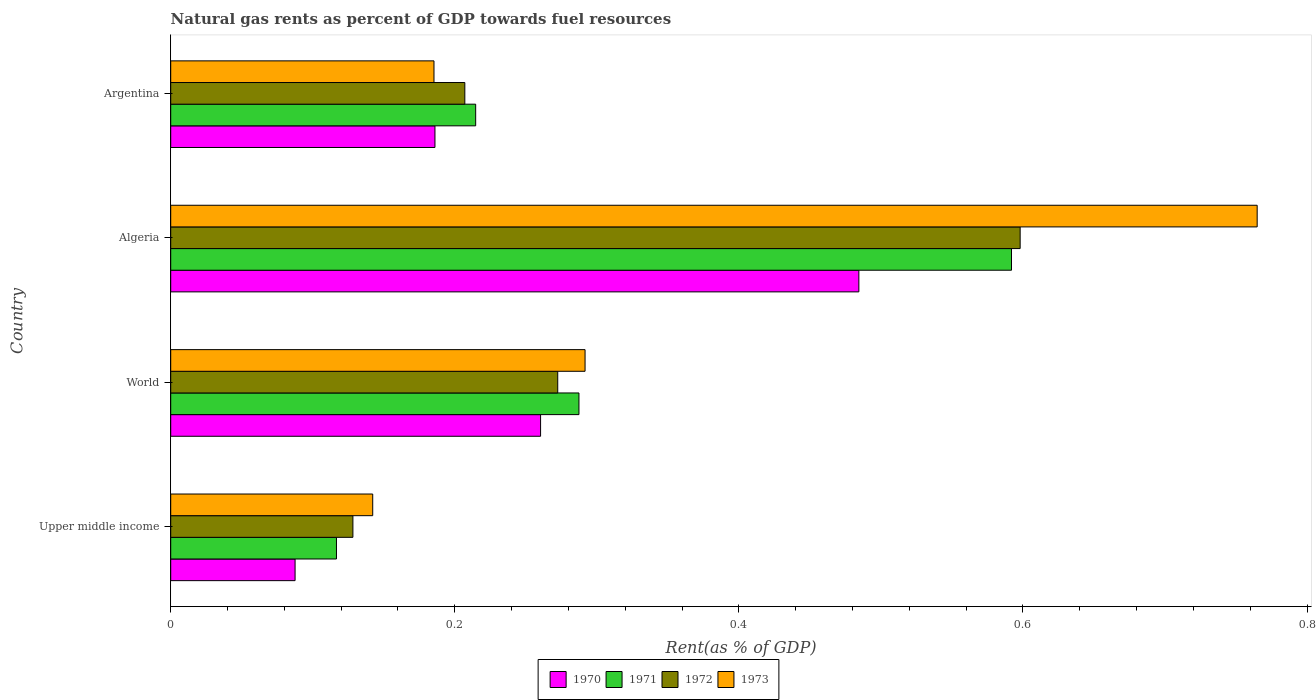How many different coloured bars are there?
Offer a very short reply. 4. How many groups of bars are there?
Provide a succinct answer. 4. What is the label of the 2nd group of bars from the top?
Make the answer very short. Algeria. What is the matural gas rent in 1971 in Argentina?
Offer a very short reply. 0.21. Across all countries, what is the maximum matural gas rent in 1970?
Your response must be concise. 0.48. Across all countries, what is the minimum matural gas rent in 1970?
Give a very brief answer. 0.09. In which country was the matural gas rent in 1971 maximum?
Make the answer very short. Algeria. In which country was the matural gas rent in 1972 minimum?
Give a very brief answer. Upper middle income. What is the total matural gas rent in 1972 in the graph?
Keep it short and to the point. 1.21. What is the difference between the matural gas rent in 1973 in Algeria and that in World?
Ensure brevity in your answer.  0.47. What is the difference between the matural gas rent in 1971 in Upper middle income and the matural gas rent in 1972 in Algeria?
Ensure brevity in your answer.  -0.48. What is the average matural gas rent in 1973 per country?
Your response must be concise. 0.35. What is the difference between the matural gas rent in 1973 and matural gas rent in 1971 in World?
Ensure brevity in your answer.  0. In how many countries, is the matural gas rent in 1972 greater than 0.52 %?
Offer a terse response. 1. What is the ratio of the matural gas rent in 1970 in Algeria to that in Argentina?
Give a very brief answer. 2.6. Is the matural gas rent in 1971 in Argentina less than that in World?
Your response must be concise. Yes. What is the difference between the highest and the second highest matural gas rent in 1973?
Ensure brevity in your answer.  0.47. What is the difference between the highest and the lowest matural gas rent in 1970?
Make the answer very short. 0.4. Is the sum of the matural gas rent in 1972 in Algeria and World greater than the maximum matural gas rent in 1970 across all countries?
Make the answer very short. Yes. Is it the case that in every country, the sum of the matural gas rent in 1973 and matural gas rent in 1971 is greater than the sum of matural gas rent in 1972 and matural gas rent in 1970?
Offer a terse response. No. What does the 1st bar from the top in Upper middle income represents?
Offer a very short reply. 1973. What does the 4th bar from the bottom in Argentina represents?
Ensure brevity in your answer.  1973. How many bars are there?
Your answer should be very brief. 16. Are all the bars in the graph horizontal?
Your answer should be very brief. Yes. How many countries are there in the graph?
Your answer should be very brief. 4. Are the values on the major ticks of X-axis written in scientific E-notation?
Provide a succinct answer. No. Does the graph contain any zero values?
Your response must be concise. No. Where does the legend appear in the graph?
Offer a very short reply. Bottom center. How are the legend labels stacked?
Provide a succinct answer. Horizontal. What is the title of the graph?
Keep it short and to the point. Natural gas rents as percent of GDP towards fuel resources. What is the label or title of the X-axis?
Offer a very short reply. Rent(as % of GDP). What is the label or title of the Y-axis?
Keep it short and to the point. Country. What is the Rent(as % of GDP) of 1970 in Upper middle income?
Ensure brevity in your answer.  0.09. What is the Rent(as % of GDP) of 1971 in Upper middle income?
Keep it short and to the point. 0.12. What is the Rent(as % of GDP) in 1972 in Upper middle income?
Offer a terse response. 0.13. What is the Rent(as % of GDP) in 1973 in Upper middle income?
Your answer should be very brief. 0.14. What is the Rent(as % of GDP) of 1970 in World?
Provide a short and direct response. 0.26. What is the Rent(as % of GDP) of 1971 in World?
Your answer should be compact. 0.29. What is the Rent(as % of GDP) in 1972 in World?
Provide a succinct answer. 0.27. What is the Rent(as % of GDP) in 1973 in World?
Provide a succinct answer. 0.29. What is the Rent(as % of GDP) of 1970 in Algeria?
Provide a succinct answer. 0.48. What is the Rent(as % of GDP) of 1971 in Algeria?
Ensure brevity in your answer.  0.59. What is the Rent(as % of GDP) in 1972 in Algeria?
Your answer should be very brief. 0.6. What is the Rent(as % of GDP) in 1973 in Algeria?
Make the answer very short. 0.76. What is the Rent(as % of GDP) of 1970 in Argentina?
Your answer should be compact. 0.19. What is the Rent(as % of GDP) in 1971 in Argentina?
Keep it short and to the point. 0.21. What is the Rent(as % of GDP) in 1972 in Argentina?
Make the answer very short. 0.21. What is the Rent(as % of GDP) in 1973 in Argentina?
Keep it short and to the point. 0.19. Across all countries, what is the maximum Rent(as % of GDP) in 1970?
Your answer should be very brief. 0.48. Across all countries, what is the maximum Rent(as % of GDP) in 1971?
Your response must be concise. 0.59. Across all countries, what is the maximum Rent(as % of GDP) of 1972?
Provide a short and direct response. 0.6. Across all countries, what is the maximum Rent(as % of GDP) of 1973?
Make the answer very short. 0.76. Across all countries, what is the minimum Rent(as % of GDP) of 1970?
Provide a short and direct response. 0.09. Across all countries, what is the minimum Rent(as % of GDP) in 1971?
Keep it short and to the point. 0.12. Across all countries, what is the minimum Rent(as % of GDP) in 1972?
Ensure brevity in your answer.  0.13. Across all countries, what is the minimum Rent(as % of GDP) in 1973?
Offer a terse response. 0.14. What is the total Rent(as % of GDP) in 1970 in the graph?
Offer a terse response. 1.02. What is the total Rent(as % of GDP) in 1971 in the graph?
Your answer should be very brief. 1.21. What is the total Rent(as % of GDP) in 1972 in the graph?
Give a very brief answer. 1.21. What is the total Rent(as % of GDP) in 1973 in the graph?
Provide a short and direct response. 1.38. What is the difference between the Rent(as % of GDP) of 1970 in Upper middle income and that in World?
Make the answer very short. -0.17. What is the difference between the Rent(as % of GDP) in 1971 in Upper middle income and that in World?
Provide a succinct answer. -0.17. What is the difference between the Rent(as % of GDP) in 1972 in Upper middle income and that in World?
Your answer should be compact. -0.14. What is the difference between the Rent(as % of GDP) in 1973 in Upper middle income and that in World?
Your response must be concise. -0.15. What is the difference between the Rent(as % of GDP) in 1970 in Upper middle income and that in Algeria?
Offer a terse response. -0.4. What is the difference between the Rent(as % of GDP) in 1971 in Upper middle income and that in Algeria?
Keep it short and to the point. -0.48. What is the difference between the Rent(as % of GDP) of 1972 in Upper middle income and that in Algeria?
Your answer should be compact. -0.47. What is the difference between the Rent(as % of GDP) of 1973 in Upper middle income and that in Algeria?
Ensure brevity in your answer.  -0.62. What is the difference between the Rent(as % of GDP) in 1970 in Upper middle income and that in Argentina?
Make the answer very short. -0.1. What is the difference between the Rent(as % of GDP) of 1971 in Upper middle income and that in Argentina?
Offer a terse response. -0.1. What is the difference between the Rent(as % of GDP) of 1972 in Upper middle income and that in Argentina?
Provide a short and direct response. -0.08. What is the difference between the Rent(as % of GDP) in 1973 in Upper middle income and that in Argentina?
Your response must be concise. -0.04. What is the difference between the Rent(as % of GDP) of 1970 in World and that in Algeria?
Your answer should be very brief. -0.22. What is the difference between the Rent(as % of GDP) in 1971 in World and that in Algeria?
Make the answer very short. -0.3. What is the difference between the Rent(as % of GDP) in 1972 in World and that in Algeria?
Your answer should be compact. -0.33. What is the difference between the Rent(as % of GDP) in 1973 in World and that in Algeria?
Make the answer very short. -0.47. What is the difference between the Rent(as % of GDP) of 1970 in World and that in Argentina?
Offer a very short reply. 0.07. What is the difference between the Rent(as % of GDP) in 1971 in World and that in Argentina?
Keep it short and to the point. 0.07. What is the difference between the Rent(as % of GDP) in 1972 in World and that in Argentina?
Your response must be concise. 0.07. What is the difference between the Rent(as % of GDP) in 1973 in World and that in Argentina?
Offer a terse response. 0.11. What is the difference between the Rent(as % of GDP) of 1970 in Algeria and that in Argentina?
Your response must be concise. 0.3. What is the difference between the Rent(as % of GDP) of 1971 in Algeria and that in Argentina?
Ensure brevity in your answer.  0.38. What is the difference between the Rent(as % of GDP) of 1972 in Algeria and that in Argentina?
Your answer should be very brief. 0.39. What is the difference between the Rent(as % of GDP) in 1973 in Algeria and that in Argentina?
Provide a short and direct response. 0.58. What is the difference between the Rent(as % of GDP) of 1970 in Upper middle income and the Rent(as % of GDP) of 1971 in World?
Offer a terse response. -0.2. What is the difference between the Rent(as % of GDP) in 1970 in Upper middle income and the Rent(as % of GDP) in 1972 in World?
Your response must be concise. -0.18. What is the difference between the Rent(as % of GDP) of 1970 in Upper middle income and the Rent(as % of GDP) of 1973 in World?
Offer a very short reply. -0.2. What is the difference between the Rent(as % of GDP) in 1971 in Upper middle income and the Rent(as % of GDP) in 1972 in World?
Provide a short and direct response. -0.16. What is the difference between the Rent(as % of GDP) in 1971 in Upper middle income and the Rent(as % of GDP) in 1973 in World?
Offer a very short reply. -0.17. What is the difference between the Rent(as % of GDP) of 1972 in Upper middle income and the Rent(as % of GDP) of 1973 in World?
Ensure brevity in your answer.  -0.16. What is the difference between the Rent(as % of GDP) in 1970 in Upper middle income and the Rent(as % of GDP) in 1971 in Algeria?
Your response must be concise. -0.5. What is the difference between the Rent(as % of GDP) in 1970 in Upper middle income and the Rent(as % of GDP) in 1972 in Algeria?
Your answer should be compact. -0.51. What is the difference between the Rent(as % of GDP) of 1970 in Upper middle income and the Rent(as % of GDP) of 1973 in Algeria?
Your response must be concise. -0.68. What is the difference between the Rent(as % of GDP) in 1971 in Upper middle income and the Rent(as % of GDP) in 1972 in Algeria?
Ensure brevity in your answer.  -0.48. What is the difference between the Rent(as % of GDP) in 1971 in Upper middle income and the Rent(as % of GDP) in 1973 in Algeria?
Provide a short and direct response. -0.65. What is the difference between the Rent(as % of GDP) of 1972 in Upper middle income and the Rent(as % of GDP) of 1973 in Algeria?
Offer a very short reply. -0.64. What is the difference between the Rent(as % of GDP) in 1970 in Upper middle income and the Rent(as % of GDP) in 1971 in Argentina?
Ensure brevity in your answer.  -0.13. What is the difference between the Rent(as % of GDP) of 1970 in Upper middle income and the Rent(as % of GDP) of 1972 in Argentina?
Your answer should be very brief. -0.12. What is the difference between the Rent(as % of GDP) in 1970 in Upper middle income and the Rent(as % of GDP) in 1973 in Argentina?
Your response must be concise. -0.1. What is the difference between the Rent(as % of GDP) in 1971 in Upper middle income and the Rent(as % of GDP) in 1972 in Argentina?
Make the answer very short. -0.09. What is the difference between the Rent(as % of GDP) in 1971 in Upper middle income and the Rent(as % of GDP) in 1973 in Argentina?
Keep it short and to the point. -0.07. What is the difference between the Rent(as % of GDP) in 1972 in Upper middle income and the Rent(as % of GDP) in 1973 in Argentina?
Your answer should be very brief. -0.06. What is the difference between the Rent(as % of GDP) of 1970 in World and the Rent(as % of GDP) of 1971 in Algeria?
Make the answer very short. -0.33. What is the difference between the Rent(as % of GDP) of 1970 in World and the Rent(as % of GDP) of 1972 in Algeria?
Keep it short and to the point. -0.34. What is the difference between the Rent(as % of GDP) in 1970 in World and the Rent(as % of GDP) in 1973 in Algeria?
Your response must be concise. -0.5. What is the difference between the Rent(as % of GDP) of 1971 in World and the Rent(as % of GDP) of 1972 in Algeria?
Ensure brevity in your answer.  -0.31. What is the difference between the Rent(as % of GDP) of 1971 in World and the Rent(as % of GDP) of 1973 in Algeria?
Give a very brief answer. -0.48. What is the difference between the Rent(as % of GDP) in 1972 in World and the Rent(as % of GDP) in 1973 in Algeria?
Provide a succinct answer. -0.49. What is the difference between the Rent(as % of GDP) of 1970 in World and the Rent(as % of GDP) of 1971 in Argentina?
Give a very brief answer. 0.05. What is the difference between the Rent(as % of GDP) of 1970 in World and the Rent(as % of GDP) of 1972 in Argentina?
Offer a terse response. 0.05. What is the difference between the Rent(as % of GDP) in 1970 in World and the Rent(as % of GDP) in 1973 in Argentina?
Your answer should be compact. 0.07. What is the difference between the Rent(as % of GDP) of 1971 in World and the Rent(as % of GDP) of 1972 in Argentina?
Offer a terse response. 0.08. What is the difference between the Rent(as % of GDP) in 1971 in World and the Rent(as % of GDP) in 1973 in Argentina?
Your response must be concise. 0.1. What is the difference between the Rent(as % of GDP) in 1972 in World and the Rent(as % of GDP) in 1973 in Argentina?
Offer a terse response. 0.09. What is the difference between the Rent(as % of GDP) in 1970 in Algeria and the Rent(as % of GDP) in 1971 in Argentina?
Make the answer very short. 0.27. What is the difference between the Rent(as % of GDP) in 1970 in Algeria and the Rent(as % of GDP) in 1972 in Argentina?
Offer a very short reply. 0.28. What is the difference between the Rent(as % of GDP) in 1970 in Algeria and the Rent(as % of GDP) in 1973 in Argentina?
Offer a very short reply. 0.3. What is the difference between the Rent(as % of GDP) in 1971 in Algeria and the Rent(as % of GDP) in 1972 in Argentina?
Ensure brevity in your answer.  0.38. What is the difference between the Rent(as % of GDP) in 1971 in Algeria and the Rent(as % of GDP) in 1973 in Argentina?
Make the answer very short. 0.41. What is the difference between the Rent(as % of GDP) in 1972 in Algeria and the Rent(as % of GDP) in 1973 in Argentina?
Offer a terse response. 0.41. What is the average Rent(as % of GDP) of 1970 per country?
Make the answer very short. 0.25. What is the average Rent(as % of GDP) in 1971 per country?
Your response must be concise. 0.3. What is the average Rent(as % of GDP) of 1972 per country?
Make the answer very short. 0.3. What is the average Rent(as % of GDP) in 1973 per country?
Your response must be concise. 0.35. What is the difference between the Rent(as % of GDP) in 1970 and Rent(as % of GDP) in 1971 in Upper middle income?
Provide a short and direct response. -0.03. What is the difference between the Rent(as % of GDP) of 1970 and Rent(as % of GDP) of 1972 in Upper middle income?
Your answer should be very brief. -0.04. What is the difference between the Rent(as % of GDP) in 1970 and Rent(as % of GDP) in 1973 in Upper middle income?
Your answer should be very brief. -0.05. What is the difference between the Rent(as % of GDP) in 1971 and Rent(as % of GDP) in 1972 in Upper middle income?
Give a very brief answer. -0.01. What is the difference between the Rent(as % of GDP) of 1971 and Rent(as % of GDP) of 1973 in Upper middle income?
Ensure brevity in your answer.  -0.03. What is the difference between the Rent(as % of GDP) of 1972 and Rent(as % of GDP) of 1973 in Upper middle income?
Offer a very short reply. -0.01. What is the difference between the Rent(as % of GDP) in 1970 and Rent(as % of GDP) in 1971 in World?
Offer a terse response. -0.03. What is the difference between the Rent(as % of GDP) of 1970 and Rent(as % of GDP) of 1972 in World?
Provide a succinct answer. -0.01. What is the difference between the Rent(as % of GDP) in 1970 and Rent(as % of GDP) in 1973 in World?
Your answer should be very brief. -0.03. What is the difference between the Rent(as % of GDP) of 1971 and Rent(as % of GDP) of 1972 in World?
Your response must be concise. 0.01. What is the difference between the Rent(as % of GDP) in 1971 and Rent(as % of GDP) in 1973 in World?
Make the answer very short. -0. What is the difference between the Rent(as % of GDP) of 1972 and Rent(as % of GDP) of 1973 in World?
Your answer should be very brief. -0.02. What is the difference between the Rent(as % of GDP) in 1970 and Rent(as % of GDP) in 1971 in Algeria?
Offer a terse response. -0.11. What is the difference between the Rent(as % of GDP) in 1970 and Rent(as % of GDP) in 1972 in Algeria?
Your response must be concise. -0.11. What is the difference between the Rent(as % of GDP) of 1970 and Rent(as % of GDP) of 1973 in Algeria?
Your answer should be very brief. -0.28. What is the difference between the Rent(as % of GDP) of 1971 and Rent(as % of GDP) of 1972 in Algeria?
Ensure brevity in your answer.  -0.01. What is the difference between the Rent(as % of GDP) of 1971 and Rent(as % of GDP) of 1973 in Algeria?
Provide a succinct answer. -0.17. What is the difference between the Rent(as % of GDP) of 1972 and Rent(as % of GDP) of 1973 in Algeria?
Make the answer very short. -0.17. What is the difference between the Rent(as % of GDP) of 1970 and Rent(as % of GDP) of 1971 in Argentina?
Offer a very short reply. -0.03. What is the difference between the Rent(as % of GDP) in 1970 and Rent(as % of GDP) in 1972 in Argentina?
Provide a succinct answer. -0.02. What is the difference between the Rent(as % of GDP) of 1970 and Rent(as % of GDP) of 1973 in Argentina?
Your response must be concise. 0. What is the difference between the Rent(as % of GDP) of 1971 and Rent(as % of GDP) of 1972 in Argentina?
Offer a very short reply. 0.01. What is the difference between the Rent(as % of GDP) in 1971 and Rent(as % of GDP) in 1973 in Argentina?
Offer a very short reply. 0.03. What is the difference between the Rent(as % of GDP) in 1972 and Rent(as % of GDP) in 1973 in Argentina?
Keep it short and to the point. 0.02. What is the ratio of the Rent(as % of GDP) of 1970 in Upper middle income to that in World?
Give a very brief answer. 0.34. What is the ratio of the Rent(as % of GDP) of 1971 in Upper middle income to that in World?
Give a very brief answer. 0.41. What is the ratio of the Rent(as % of GDP) in 1972 in Upper middle income to that in World?
Keep it short and to the point. 0.47. What is the ratio of the Rent(as % of GDP) in 1973 in Upper middle income to that in World?
Provide a succinct answer. 0.49. What is the ratio of the Rent(as % of GDP) in 1970 in Upper middle income to that in Algeria?
Your answer should be very brief. 0.18. What is the ratio of the Rent(as % of GDP) in 1971 in Upper middle income to that in Algeria?
Give a very brief answer. 0.2. What is the ratio of the Rent(as % of GDP) in 1972 in Upper middle income to that in Algeria?
Provide a short and direct response. 0.21. What is the ratio of the Rent(as % of GDP) in 1973 in Upper middle income to that in Algeria?
Your answer should be compact. 0.19. What is the ratio of the Rent(as % of GDP) in 1970 in Upper middle income to that in Argentina?
Give a very brief answer. 0.47. What is the ratio of the Rent(as % of GDP) in 1971 in Upper middle income to that in Argentina?
Your answer should be compact. 0.54. What is the ratio of the Rent(as % of GDP) of 1972 in Upper middle income to that in Argentina?
Offer a very short reply. 0.62. What is the ratio of the Rent(as % of GDP) in 1973 in Upper middle income to that in Argentina?
Your answer should be very brief. 0.77. What is the ratio of the Rent(as % of GDP) in 1970 in World to that in Algeria?
Provide a short and direct response. 0.54. What is the ratio of the Rent(as % of GDP) in 1971 in World to that in Algeria?
Your answer should be very brief. 0.49. What is the ratio of the Rent(as % of GDP) of 1972 in World to that in Algeria?
Your answer should be very brief. 0.46. What is the ratio of the Rent(as % of GDP) of 1973 in World to that in Algeria?
Offer a very short reply. 0.38. What is the ratio of the Rent(as % of GDP) of 1970 in World to that in Argentina?
Offer a very short reply. 1.4. What is the ratio of the Rent(as % of GDP) of 1971 in World to that in Argentina?
Make the answer very short. 1.34. What is the ratio of the Rent(as % of GDP) of 1972 in World to that in Argentina?
Offer a terse response. 1.32. What is the ratio of the Rent(as % of GDP) of 1973 in World to that in Argentina?
Your answer should be very brief. 1.57. What is the ratio of the Rent(as % of GDP) in 1970 in Algeria to that in Argentina?
Make the answer very short. 2.6. What is the ratio of the Rent(as % of GDP) of 1971 in Algeria to that in Argentina?
Your answer should be compact. 2.76. What is the ratio of the Rent(as % of GDP) in 1972 in Algeria to that in Argentina?
Provide a short and direct response. 2.89. What is the ratio of the Rent(as % of GDP) of 1973 in Algeria to that in Argentina?
Keep it short and to the point. 4.13. What is the difference between the highest and the second highest Rent(as % of GDP) of 1970?
Offer a very short reply. 0.22. What is the difference between the highest and the second highest Rent(as % of GDP) in 1971?
Provide a succinct answer. 0.3. What is the difference between the highest and the second highest Rent(as % of GDP) of 1972?
Give a very brief answer. 0.33. What is the difference between the highest and the second highest Rent(as % of GDP) in 1973?
Offer a terse response. 0.47. What is the difference between the highest and the lowest Rent(as % of GDP) of 1970?
Your answer should be very brief. 0.4. What is the difference between the highest and the lowest Rent(as % of GDP) in 1971?
Your response must be concise. 0.48. What is the difference between the highest and the lowest Rent(as % of GDP) in 1972?
Ensure brevity in your answer.  0.47. What is the difference between the highest and the lowest Rent(as % of GDP) in 1973?
Offer a very short reply. 0.62. 